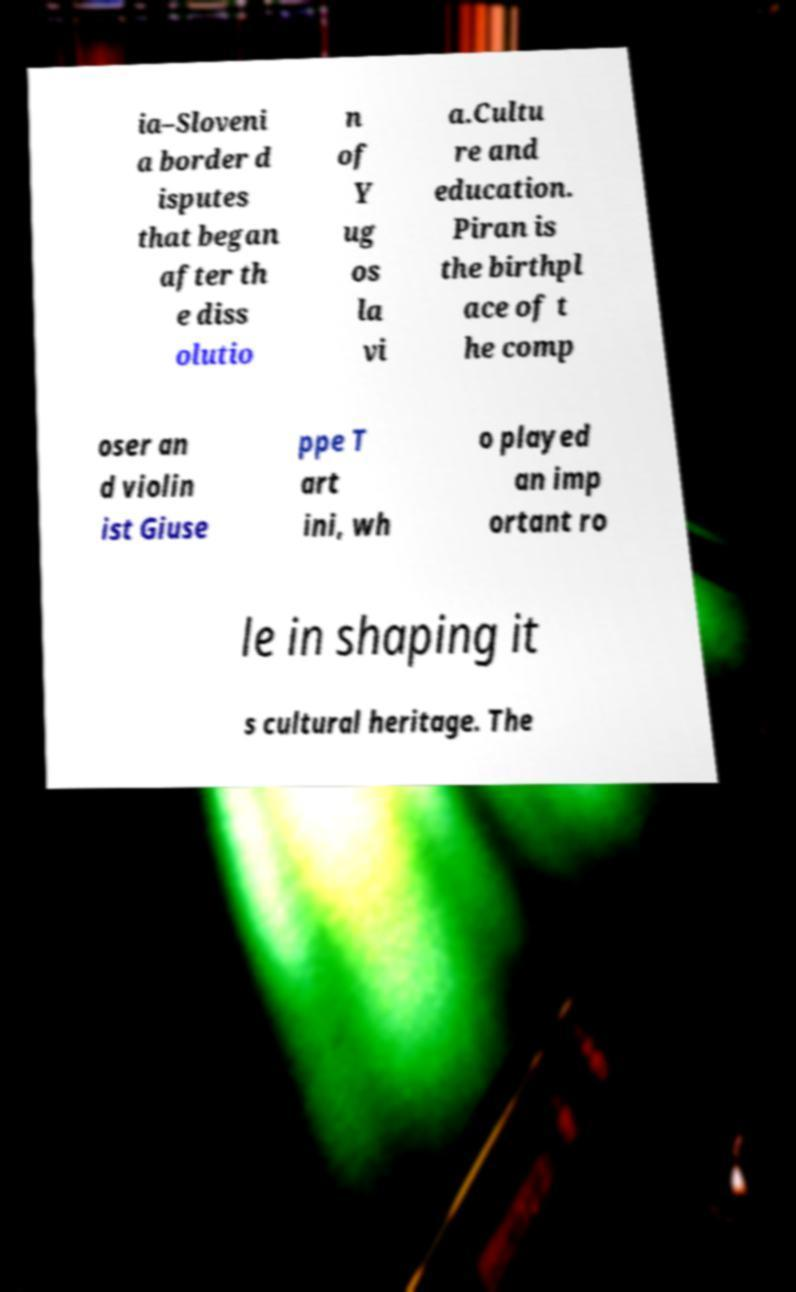Could you assist in decoding the text presented in this image and type it out clearly? ia–Sloveni a border d isputes that began after th e diss olutio n of Y ug os la vi a.Cultu re and education. Piran is the birthpl ace of t he comp oser an d violin ist Giuse ppe T art ini, wh o played an imp ortant ro le in shaping it s cultural heritage. The 